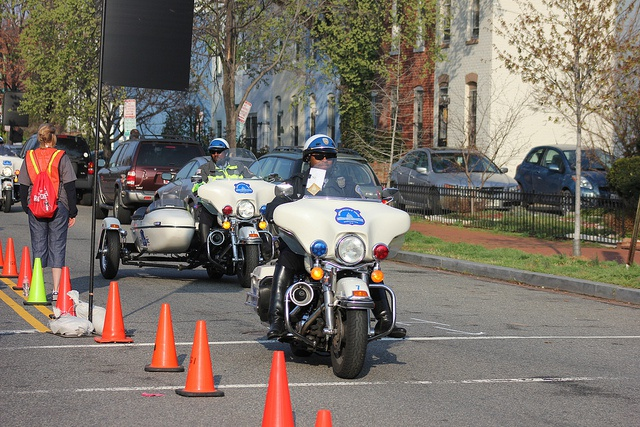Describe the objects in this image and their specific colors. I can see motorcycle in olive, black, ivory, gray, and darkgray tones, motorcycle in olive, black, ivory, gray, and darkgray tones, car in olive, gray, black, and darkgray tones, car in olive, black, gray, navy, and darkgray tones, and car in olive, black, gray, and maroon tones in this image. 